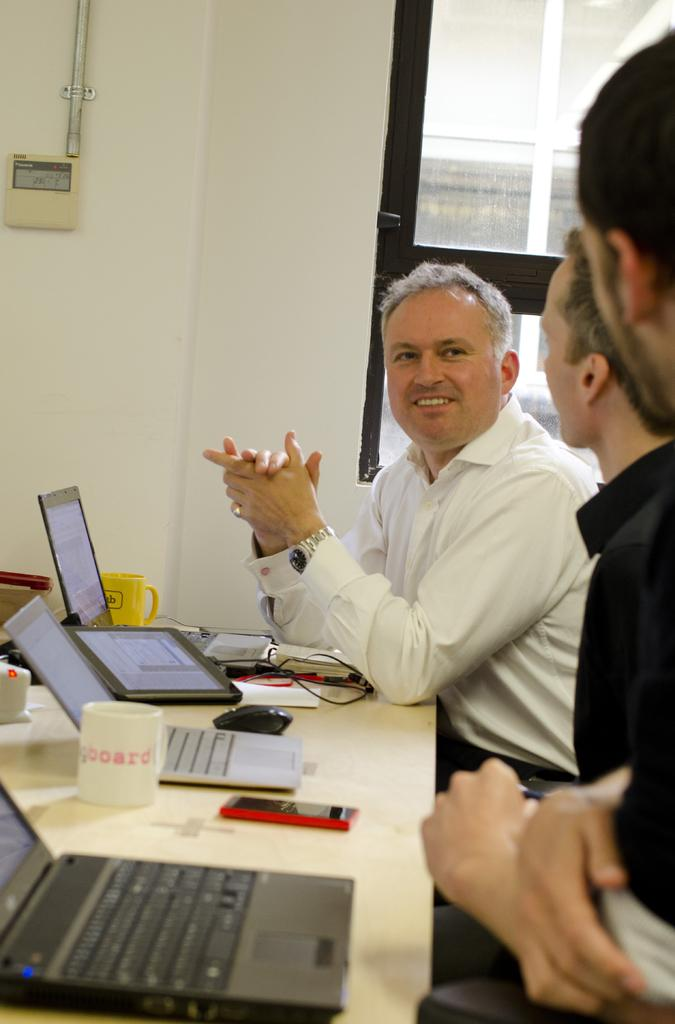<image>
Present a compact description of the photo's key features. Three people sit at a table with their computers out as well as a coffee cup marked board. 